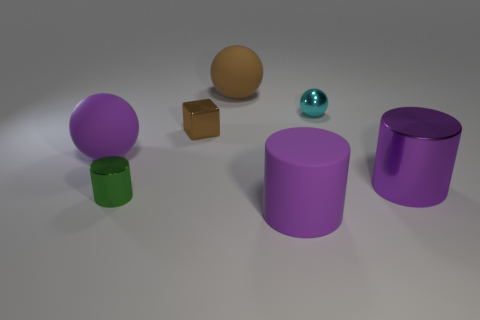Add 3 yellow shiny blocks. How many objects exist? 10 Subtract all spheres. How many objects are left? 4 Subtract all tiny things. Subtract all tiny metallic spheres. How many objects are left? 3 Add 4 small brown metal cubes. How many small brown metal cubes are left? 5 Add 4 big brown shiny balls. How many big brown shiny balls exist? 4 Subtract 0 gray balls. How many objects are left? 7 